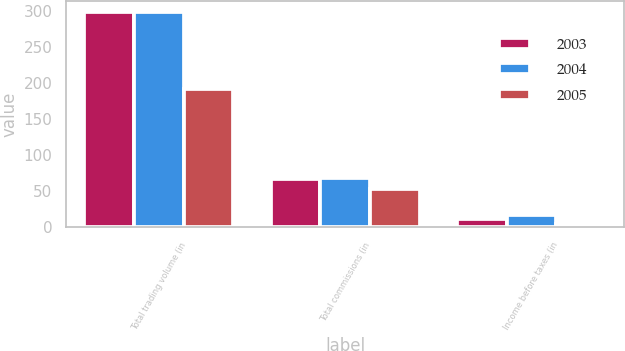Convert chart. <chart><loc_0><loc_0><loc_500><loc_500><stacked_bar_chart><ecel><fcel>Total trading volume (in<fcel>Total commissions (in<fcel>Income before taxes (in<nl><fcel>2003<fcel>299.2<fcel>66.9<fcel>11.6<nl><fcel>2004<fcel>298.1<fcel>68.2<fcel>17.3<nl><fcel>2005<fcel>192.2<fcel>52.8<fcel>4.4<nl></chart> 